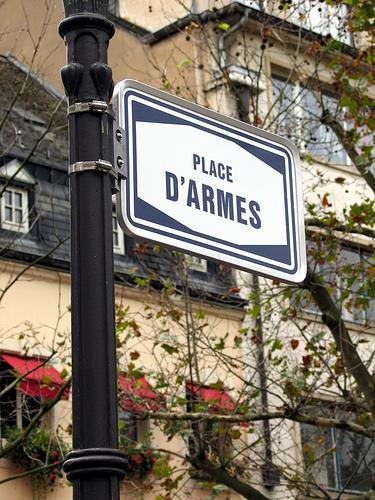Question: where was this photo taken?
Choices:
A. Place D'armes.
B. In New Orlean's.
C. Mardi Gras parade.
D. At Jackson Square.
Answer with the letter. Answer: A Question: who is in the photo?
Choices:
A. The team.
B. Noone.
C. The family.
D. The band.
Answer with the letter. Answer: B Question: what else is in the photo?
Choices:
A. Ducks.
B. Trees.
C. Buildings.
D. Clouds.
Answer with the letter. Answer: C 